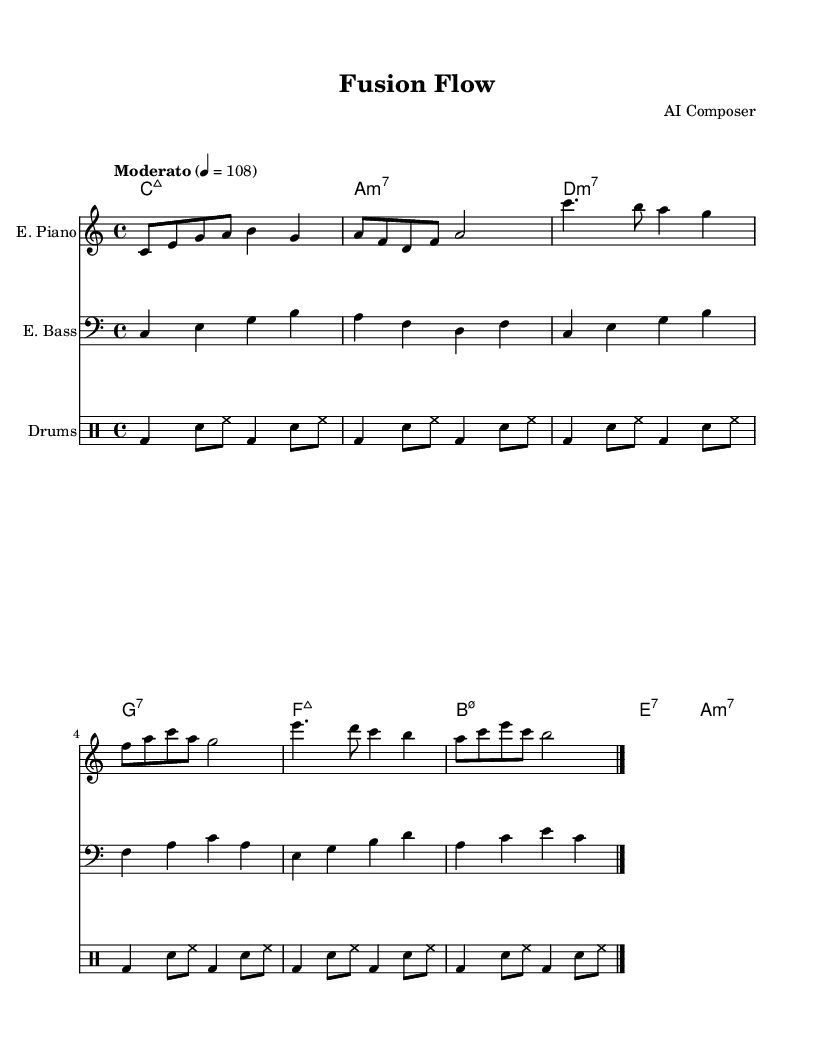What is the key signature of this music? The music is in the key of C major, which has no sharps or flats indicated in the key signature.
Answer: C major What is the time signature of this music? The time signature shown at the beginning of the score is 4/4, which means there are four beats per measure.
Answer: 4/4 What is the tempo marking for this piece? The tempo marking is "Moderato," with a metronome marking of 108 beats per minute, which indicates a moderate speed.
Answer: Moderato How many measures are there in the electric piano part? By counting the distinct measures in the electric piano part, there are eleven measures in total.
Answer: 11 Which chord is used at the beginning of the score? The first chord indicated in the chord names section is C major 7 (C:maj7) which is the tonic chord for the key of C major.
Answer: C:maj7 What type of instruments are used in this piece? The score features three instruments: electric piano, electric bass, and drums, as specified at the beginning of each staff.
Answer: Electric piano, electric bass, drums How does the bass line relate to the chord progression? The bass line generally outlines the root notes of the chords indicated above it, matching the chord changes in a predictable manner that supports the harmonic structure.
Answer: Supports harmonic structure 